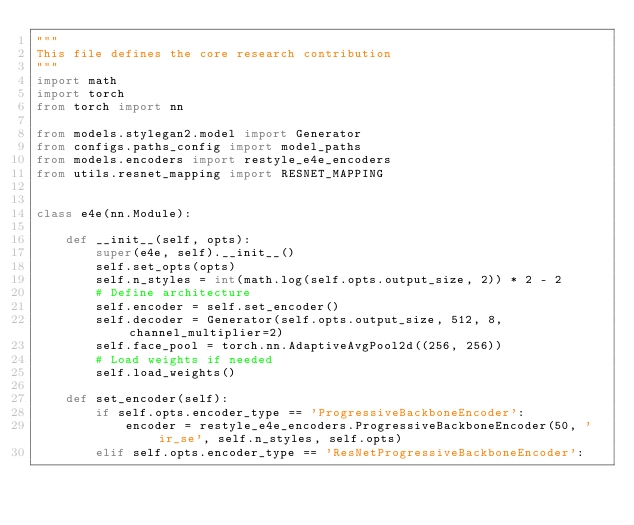<code> <loc_0><loc_0><loc_500><loc_500><_Python_>"""
This file defines the core research contribution
"""
import math
import torch
from torch import nn

from models.stylegan2.model import Generator
from configs.paths_config import model_paths
from models.encoders import restyle_e4e_encoders
from utils.resnet_mapping import RESNET_MAPPING


class e4e(nn.Module):

    def __init__(self, opts):
        super(e4e, self).__init__()
        self.set_opts(opts)
        self.n_styles = int(math.log(self.opts.output_size, 2)) * 2 - 2
        # Define architecture
        self.encoder = self.set_encoder()
        self.decoder = Generator(self.opts.output_size, 512, 8, channel_multiplier=2)
        self.face_pool = torch.nn.AdaptiveAvgPool2d((256, 256))
        # Load weights if needed
        self.load_weights()

    def set_encoder(self):
        if self.opts.encoder_type == 'ProgressiveBackboneEncoder':
            encoder = restyle_e4e_encoders.ProgressiveBackboneEncoder(50, 'ir_se', self.n_styles, self.opts)
        elif self.opts.encoder_type == 'ResNetProgressiveBackboneEncoder':</code> 